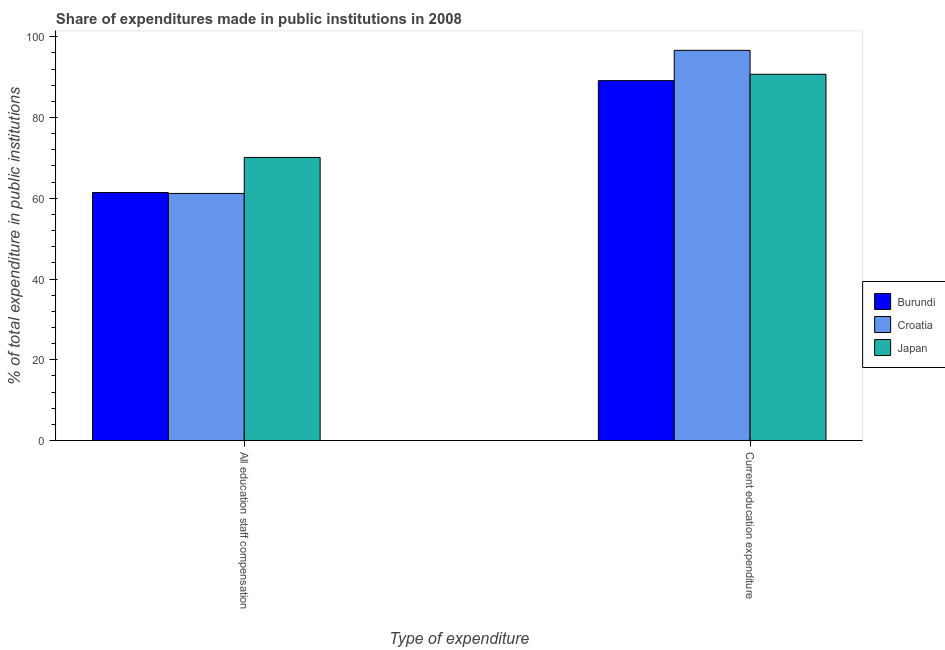Are the number of bars per tick equal to the number of legend labels?
Your answer should be very brief. Yes. How many bars are there on the 1st tick from the left?
Offer a terse response. 3. How many bars are there on the 2nd tick from the right?
Offer a terse response. 3. What is the label of the 2nd group of bars from the left?
Your answer should be very brief. Current education expenditure. What is the expenditure in education in Japan?
Make the answer very short. 90.7. Across all countries, what is the maximum expenditure in education?
Your response must be concise. 96.63. Across all countries, what is the minimum expenditure in education?
Make the answer very short. 89.13. In which country was the expenditure in education maximum?
Ensure brevity in your answer.  Croatia. In which country was the expenditure in education minimum?
Offer a terse response. Burundi. What is the total expenditure in staff compensation in the graph?
Make the answer very short. 192.74. What is the difference between the expenditure in staff compensation in Croatia and that in Japan?
Provide a short and direct response. -8.91. What is the difference between the expenditure in staff compensation in Burundi and the expenditure in education in Japan?
Make the answer very short. -29.28. What is the average expenditure in education per country?
Your answer should be very brief. 92.16. What is the difference between the expenditure in staff compensation and expenditure in education in Japan?
Provide a short and direct response. -20.59. What is the ratio of the expenditure in staff compensation in Japan to that in Croatia?
Ensure brevity in your answer.  1.15. In how many countries, is the expenditure in education greater than the average expenditure in education taken over all countries?
Make the answer very short. 1. How many bars are there?
Keep it short and to the point. 6. How many countries are there in the graph?
Your answer should be compact. 3. How many legend labels are there?
Provide a succinct answer. 3. What is the title of the graph?
Keep it short and to the point. Share of expenditures made in public institutions in 2008. Does "Sub-Saharan Africa (developing only)" appear as one of the legend labels in the graph?
Keep it short and to the point. No. What is the label or title of the X-axis?
Ensure brevity in your answer.  Type of expenditure. What is the label or title of the Y-axis?
Your answer should be compact. % of total expenditure in public institutions. What is the % of total expenditure in public institutions in Burundi in All education staff compensation?
Your answer should be compact. 61.43. What is the % of total expenditure in public institutions in Croatia in All education staff compensation?
Give a very brief answer. 61.2. What is the % of total expenditure in public institutions of Japan in All education staff compensation?
Offer a terse response. 70.11. What is the % of total expenditure in public institutions of Burundi in Current education expenditure?
Offer a very short reply. 89.13. What is the % of total expenditure in public institutions in Croatia in Current education expenditure?
Ensure brevity in your answer.  96.63. What is the % of total expenditure in public institutions of Japan in Current education expenditure?
Keep it short and to the point. 90.7. Across all Type of expenditure, what is the maximum % of total expenditure in public institutions in Burundi?
Provide a short and direct response. 89.13. Across all Type of expenditure, what is the maximum % of total expenditure in public institutions of Croatia?
Keep it short and to the point. 96.63. Across all Type of expenditure, what is the maximum % of total expenditure in public institutions in Japan?
Give a very brief answer. 90.7. Across all Type of expenditure, what is the minimum % of total expenditure in public institutions in Burundi?
Provide a short and direct response. 61.43. Across all Type of expenditure, what is the minimum % of total expenditure in public institutions in Croatia?
Your answer should be compact. 61.2. Across all Type of expenditure, what is the minimum % of total expenditure in public institutions of Japan?
Your answer should be compact. 70.11. What is the total % of total expenditure in public institutions in Burundi in the graph?
Make the answer very short. 150.56. What is the total % of total expenditure in public institutions of Croatia in the graph?
Your response must be concise. 157.83. What is the total % of total expenditure in public institutions in Japan in the graph?
Offer a terse response. 160.81. What is the difference between the % of total expenditure in public institutions in Burundi in All education staff compensation and that in Current education expenditure?
Offer a terse response. -27.7. What is the difference between the % of total expenditure in public institutions in Croatia in All education staff compensation and that in Current education expenditure?
Your answer should be very brief. -35.43. What is the difference between the % of total expenditure in public institutions in Japan in All education staff compensation and that in Current education expenditure?
Your answer should be compact. -20.59. What is the difference between the % of total expenditure in public institutions of Burundi in All education staff compensation and the % of total expenditure in public institutions of Croatia in Current education expenditure?
Provide a succinct answer. -35.21. What is the difference between the % of total expenditure in public institutions of Burundi in All education staff compensation and the % of total expenditure in public institutions of Japan in Current education expenditure?
Your response must be concise. -29.28. What is the difference between the % of total expenditure in public institutions in Croatia in All education staff compensation and the % of total expenditure in public institutions in Japan in Current education expenditure?
Offer a terse response. -29.5. What is the average % of total expenditure in public institutions of Burundi per Type of expenditure?
Your response must be concise. 75.28. What is the average % of total expenditure in public institutions in Croatia per Type of expenditure?
Give a very brief answer. 78.92. What is the average % of total expenditure in public institutions in Japan per Type of expenditure?
Ensure brevity in your answer.  80.41. What is the difference between the % of total expenditure in public institutions in Burundi and % of total expenditure in public institutions in Croatia in All education staff compensation?
Offer a terse response. 0.22. What is the difference between the % of total expenditure in public institutions in Burundi and % of total expenditure in public institutions in Japan in All education staff compensation?
Your answer should be very brief. -8.69. What is the difference between the % of total expenditure in public institutions in Croatia and % of total expenditure in public institutions in Japan in All education staff compensation?
Your answer should be compact. -8.91. What is the difference between the % of total expenditure in public institutions in Burundi and % of total expenditure in public institutions in Croatia in Current education expenditure?
Provide a succinct answer. -7.5. What is the difference between the % of total expenditure in public institutions of Burundi and % of total expenditure in public institutions of Japan in Current education expenditure?
Provide a succinct answer. -1.57. What is the difference between the % of total expenditure in public institutions of Croatia and % of total expenditure in public institutions of Japan in Current education expenditure?
Give a very brief answer. 5.93. What is the ratio of the % of total expenditure in public institutions in Burundi in All education staff compensation to that in Current education expenditure?
Offer a very short reply. 0.69. What is the ratio of the % of total expenditure in public institutions of Croatia in All education staff compensation to that in Current education expenditure?
Give a very brief answer. 0.63. What is the ratio of the % of total expenditure in public institutions in Japan in All education staff compensation to that in Current education expenditure?
Ensure brevity in your answer.  0.77. What is the difference between the highest and the second highest % of total expenditure in public institutions of Burundi?
Give a very brief answer. 27.7. What is the difference between the highest and the second highest % of total expenditure in public institutions of Croatia?
Provide a succinct answer. 35.43. What is the difference between the highest and the second highest % of total expenditure in public institutions in Japan?
Provide a short and direct response. 20.59. What is the difference between the highest and the lowest % of total expenditure in public institutions in Burundi?
Offer a terse response. 27.7. What is the difference between the highest and the lowest % of total expenditure in public institutions of Croatia?
Offer a very short reply. 35.43. What is the difference between the highest and the lowest % of total expenditure in public institutions of Japan?
Provide a short and direct response. 20.59. 